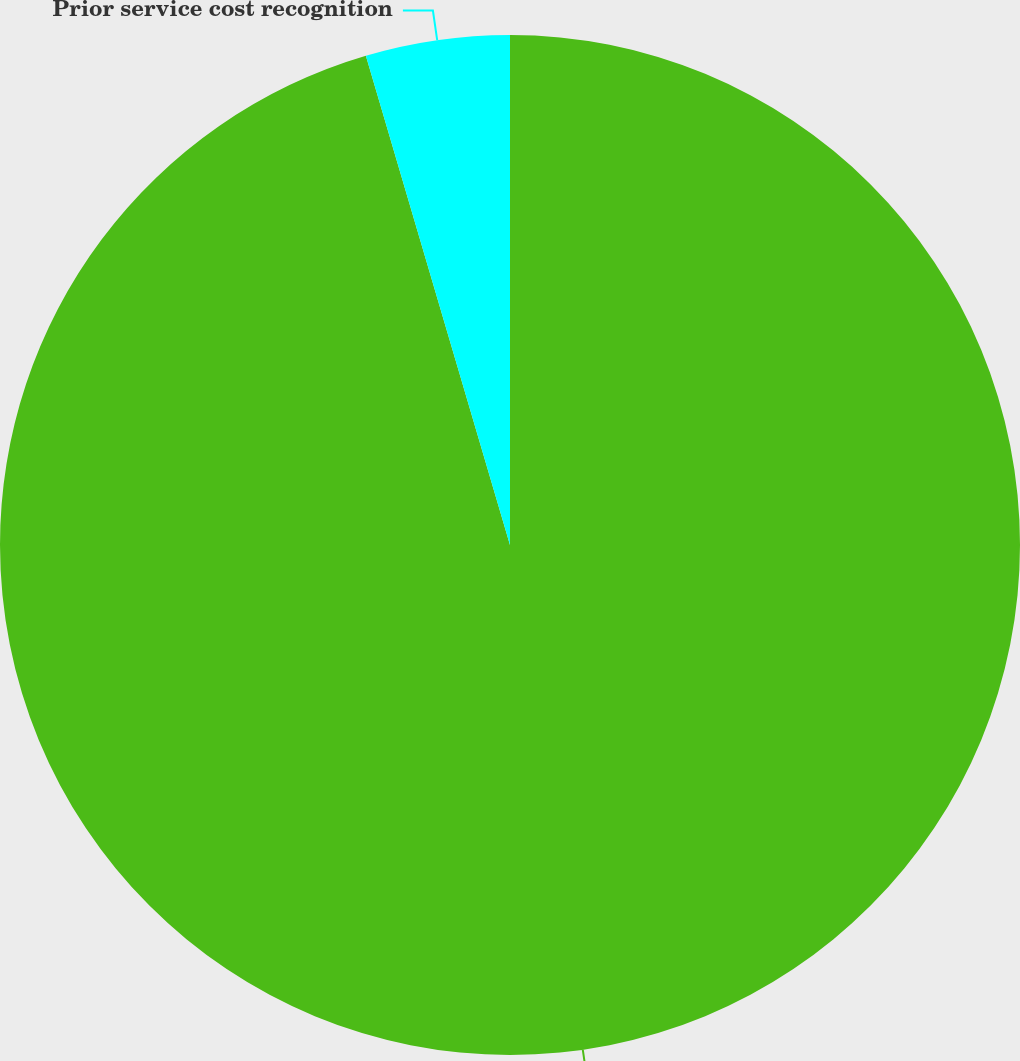Convert chart. <chart><loc_0><loc_0><loc_500><loc_500><pie_chart><fcel>Loss recognition<fcel>Prior service cost recognition<nl><fcel>95.44%<fcel>4.56%<nl></chart> 